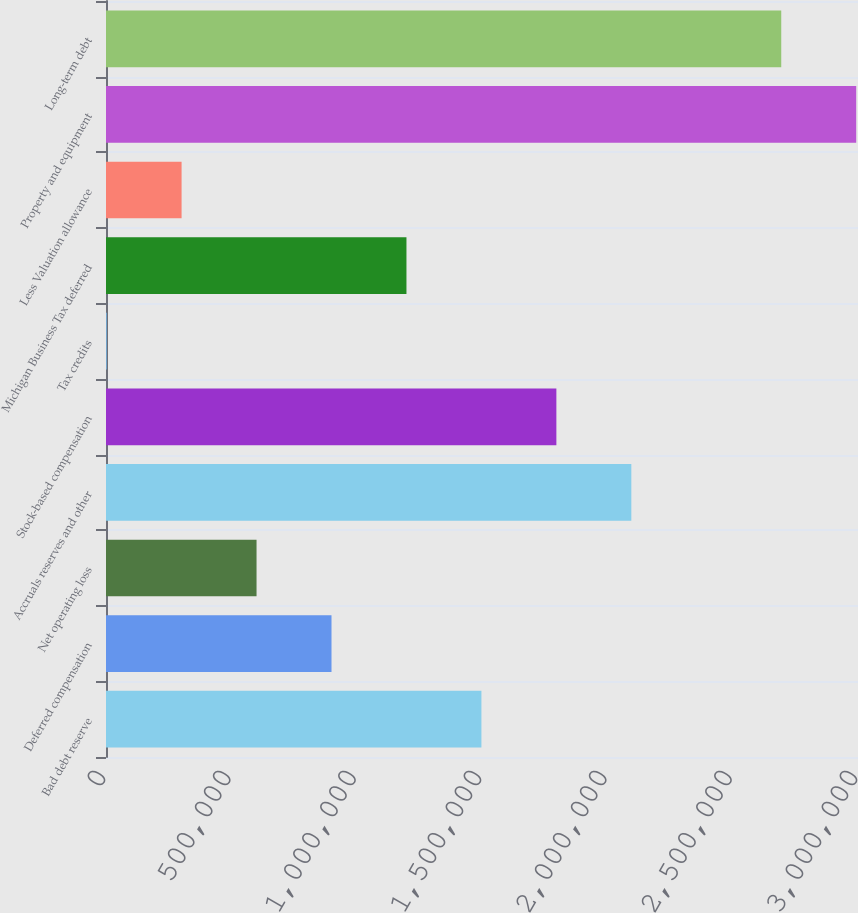<chart> <loc_0><loc_0><loc_500><loc_500><bar_chart><fcel>Bad debt reserve<fcel>Deferred compensation<fcel>Net operating loss<fcel>Accruals reserves and other<fcel>Stock-based compensation<fcel>Tax credits<fcel>Michigan Business Tax deferred<fcel>Less Valuation allowance<fcel>Property and equipment<fcel>Long-term debt<nl><fcel>1.49765e+06<fcel>899588<fcel>600556<fcel>2.09572e+06<fcel>1.79669e+06<fcel>2491<fcel>1.19862e+06<fcel>301524<fcel>2.99282e+06<fcel>2.69378e+06<nl></chart> 